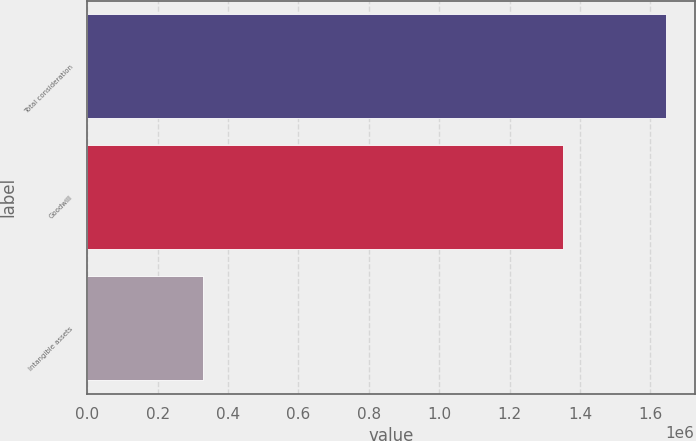Convert chart to OTSL. <chart><loc_0><loc_0><loc_500><loc_500><bar_chart><fcel>Total consideration<fcel>Goodwill<fcel>Intangible assets<nl><fcel>1.6432e+06<fcel>1.35097e+06<fcel>328776<nl></chart> 